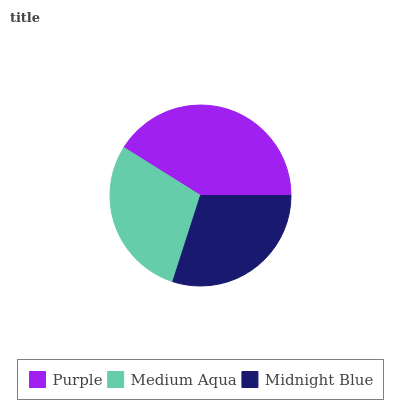Is Medium Aqua the minimum?
Answer yes or no. Yes. Is Purple the maximum?
Answer yes or no. Yes. Is Midnight Blue the minimum?
Answer yes or no. No. Is Midnight Blue the maximum?
Answer yes or no. No. Is Midnight Blue greater than Medium Aqua?
Answer yes or no. Yes. Is Medium Aqua less than Midnight Blue?
Answer yes or no. Yes. Is Medium Aqua greater than Midnight Blue?
Answer yes or no. No. Is Midnight Blue less than Medium Aqua?
Answer yes or no. No. Is Midnight Blue the high median?
Answer yes or no. Yes. Is Midnight Blue the low median?
Answer yes or no. Yes. Is Medium Aqua the high median?
Answer yes or no. No. Is Medium Aqua the low median?
Answer yes or no. No. 